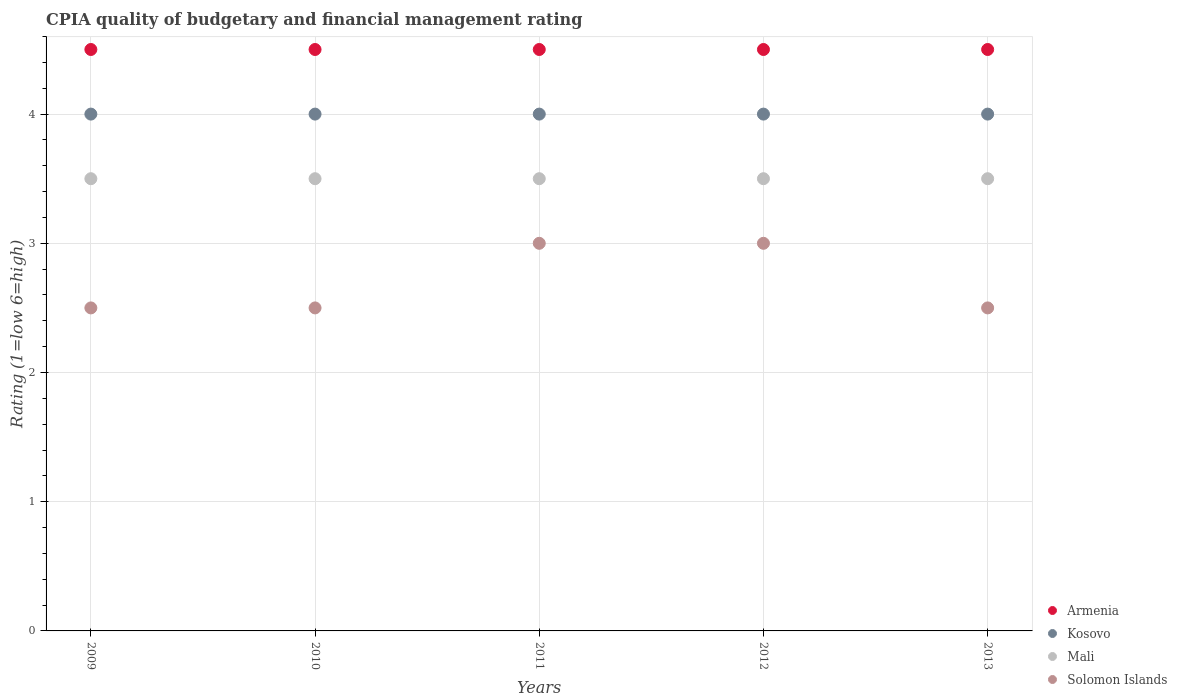How many different coloured dotlines are there?
Give a very brief answer. 4. Across all years, what is the maximum CPIA rating in Solomon Islands?
Offer a terse response. 3. In which year was the CPIA rating in Kosovo minimum?
Your response must be concise. 2009. What is the difference between the CPIA rating in Mali in 2009 and that in 2012?
Keep it short and to the point. 0. What is the average CPIA rating in Armenia per year?
Provide a short and direct response. 4.5. In the year 2013, what is the difference between the CPIA rating in Armenia and CPIA rating in Mali?
Your answer should be compact. 1. What is the ratio of the CPIA rating in Kosovo in 2009 to that in 2013?
Ensure brevity in your answer.  1. What is the difference between the highest and the second highest CPIA rating in Kosovo?
Make the answer very short. 0. What is the difference between the highest and the lowest CPIA rating in Solomon Islands?
Offer a very short reply. 0.5. In how many years, is the CPIA rating in Mali greater than the average CPIA rating in Mali taken over all years?
Your answer should be very brief. 0. Is the CPIA rating in Solomon Islands strictly greater than the CPIA rating in Kosovo over the years?
Keep it short and to the point. No. How many years are there in the graph?
Your answer should be very brief. 5. Does the graph contain any zero values?
Offer a terse response. No. Does the graph contain grids?
Give a very brief answer. Yes. Where does the legend appear in the graph?
Offer a terse response. Bottom right. How many legend labels are there?
Your response must be concise. 4. How are the legend labels stacked?
Offer a very short reply. Vertical. What is the title of the graph?
Make the answer very short. CPIA quality of budgetary and financial management rating. What is the Rating (1=low 6=high) in Armenia in 2009?
Keep it short and to the point. 4.5. What is the Rating (1=low 6=high) of Solomon Islands in 2009?
Provide a succinct answer. 2.5. What is the Rating (1=low 6=high) of Mali in 2010?
Ensure brevity in your answer.  3.5. What is the Rating (1=low 6=high) in Solomon Islands in 2010?
Offer a terse response. 2.5. What is the Rating (1=low 6=high) in Armenia in 2011?
Ensure brevity in your answer.  4.5. What is the Rating (1=low 6=high) in Kosovo in 2011?
Make the answer very short. 4. What is the Rating (1=low 6=high) in Solomon Islands in 2011?
Ensure brevity in your answer.  3. What is the Rating (1=low 6=high) of Armenia in 2012?
Make the answer very short. 4.5. What is the Rating (1=low 6=high) of Mali in 2012?
Provide a short and direct response. 3.5. What is the Rating (1=low 6=high) in Armenia in 2013?
Ensure brevity in your answer.  4.5. What is the Rating (1=low 6=high) in Mali in 2013?
Offer a very short reply. 3.5. What is the Rating (1=low 6=high) in Solomon Islands in 2013?
Make the answer very short. 2.5. Across all years, what is the maximum Rating (1=low 6=high) in Armenia?
Offer a very short reply. 4.5. Across all years, what is the maximum Rating (1=low 6=high) of Kosovo?
Offer a terse response. 4. Across all years, what is the maximum Rating (1=low 6=high) of Mali?
Offer a terse response. 3.5. Across all years, what is the minimum Rating (1=low 6=high) of Kosovo?
Ensure brevity in your answer.  4. Across all years, what is the minimum Rating (1=low 6=high) in Mali?
Make the answer very short. 3.5. What is the total Rating (1=low 6=high) in Armenia in the graph?
Give a very brief answer. 22.5. What is the total Rating (1=low 6=high) of Kosovo in the graph?
Ensure brevity in your answer.  20. What is the total Rating (1=low 6=high) in Mali in the graph?
Give a very brief answer. 17.5. What is the total Rating (1=low 6=high) of Solomon Islands in the graph?
Your answer should be compact. 13.5. What is the difference between the Rating (1=low 6=high) in Solomon Islands in 2009 and that in 2010?
Offer a terse response. 0. What is the difference between the Rating (1=low 6=high) in Mali in 2009 and that in 2011?
Ensure brevity in your answer.  0. What is the difference between the Rating (1=low 6=high) of Solomon Islands in 2009 and that in 2012?
Offer a very short reply. -0.5. What is the difference between the Rating (1=low 6=high) of Armenia in 2009 and that in 2013?
Keep it short and to the point. 0. What is the difference between the Rating (1=low 6=high) in Armenia in 2010 and that in 2011?
Ensure brevity in your answer.  0. What is the difference between the Rating (1=low 6=high) of Mali in 2010 and that in 2011?
Provide a short and direct response. 0. What is the difference between the Rating (1=low 6=high) of Kosovo in 2010 and that in 2012?
Keep it short and to the point. 0. What is the difference between the Rating (1=low 6=high) in Mali in 2010 and that in 2012?
Give a very brief answer. 0. What is the difference between the Rating (1=low 6=high) of Solomon Islands in 2010 and that in 2012?
Your response must be concise. -0.5. What is the difference between the Rating (1=low 6=high) of Armenia in 2010 and that in 2013?
Make the answer very short. 0. What is the difference between the Rating (1=low 6=high) in Mali in 2010 and that in 2013?
Your response must be concise. 0. What is the difference between the Rating (1=low 6=high) in Armenia in 2011 and that in 2012?
Provide a short and direct response. 0. What is the difference between the Rating (1=low 6=high) in Solomon Islands in 2011 and that in 2012?
Your answer should be compact. 0. What is the difference between the Rating (1=low 6=high) in Armenia in 2011 and that in 2013?
Ensure brevity in your answer.  0. What is the difference between the Rating (1=low 6=high) of Solomon Islands in 2011 and that in 2013?
Make the answer very short. 0.5. What is the difference between the Rating (1=low 6=high) of Kosovo in 2012 and that in 2013?
Offer a terse response. 0. What is the difference between the Rating (1=low 6=high) of Kosovo in 2009 and the Rating (1=low 6=high) of Mali in 2010?
Your answer should be compact. 0.5. What is the difference between the Rating (1=low 6=high) of Armenia in 2009 and the Rating (1=low 6=high) of Kosovo in 2012?
Make the answer very short. 0.5. What is the difference between the Rating (1=low 6=high) of Armenia in 2009 and the Rating (1=low 6=high) of Mali in 2012?
Offer a very short reply. 1. What is the difference between the Rating (1=low 6=high) of Armenia in 2009 and the Rating (1=low 6=high) of Solomon Islands in 2012?
Your answer should be very brief. 1.5. What is the difference between the Rating (1=low 6=high) in Kosovo in 2009 and the Rating (1=low 6=high) in Solomon Islands in 2012?
Your answer should be compact. 1. What is the difference between the Rating (1=low 6=high) of Armenia in 2009 and the Rating (1=low 6=high) of Kosovo in 2013?
Your answer should be compact. 0.5. What is the difference between the Rating (1=low 6=high) in Armenia in 2009 and the Rating (1=low 6=high) in Solomon Islands in 2013?
Make the answer very short. 2. What is the difference between the Rating (1=low 6=high) of Mali in 2009 and the Rating (1=low 6=high) of Solomon Islands in 2013?
Make the answer very short. 1. What is the difference between the Rating (1=low 6=high) in Armenia in 2010 and the Rating (1=low 6=high) in Kosovo in 2011?
Your answer should be compact. 0.5. What is the difference between the Rating (1=low 6=high) in Armenia in 2010 and the Rating (1=low 6=high) in Mali in 2011?
Offer a terse response. 1. What is the difference between the Rating (1=low 6=high) of Armenia in 2010 and the Rating (1=low 6=high) of Solomon Islands in 2011?
Your response must be concise. 1.5. What is the difference between the Rating (1=low 6=high) in Kosovo in 2010 and the Rating (1=low 6=high) in Solomon Islands in 2011?
Offer a very short reply. 1. What is the difference between the Rating (1=low 6=high) in Armenia in 2010 and the Rating (1=low 6=high) in Mali in 2012?
Keep it short and to the point. 1. What is the difference between the Rating (1=low 6=high) of Kosovo in 2010 and the Rating (1=low 6=high) of Mali in 2012?
Make the answer very short. 0.5. What is the difference between the Rating (1=low 6=high) in Mali in 2010 and the Rating (1=low 6=high) in Solomon Islands in 2012?
Provide a succinct answer. 0.5. What is the difference between the Rating (1=low 6=high) of Armenia in 2010 and the Rating (1=low 6=high) of Solomon Islands in 2013?
Your answer should be very brief. 2. What is the difference between the Rating (1=low 6=high) in Kosovo in 2010 and the Rating (1=low 6=high) in Mali in 2013?
Provide a succinct answer. 0.5. What is the difference between the Rating (1=low 6=high) in Armenia in 2011 and the Rating (1=low 6=high) in Mali in 2012?
Offer a terse response. 1. What is the difference between the Rating (1=low 6=high) in Kosovo in 2011 and the Rating (1=low 6=high) in Solomon Islands in 2012?
Offer a very short reply. 1. What is the difference between the Rating (1=low 6=high) of Mali in 2011 and the Rating (1=low 6=high) of Solomon Islands in 2012?
Give a very brief answer. 0.5. What is the difference between the Rating (1=low 6=high) of Armenia in 2011 and the Rating (1=low 6=high) of Kosovo in 2013?
Ensure brevity in your answer.  0.5. What is the difference between the Rating (1=low 6=high) of Kosovo in 2011 and the Rating (1=low 6=high) of Solomon Islands in 2013?
Your answer should be compact. 1.5. What is the difference between the Rating (1=low 6=high) in Mali in 2011 and the Rating (1=low 6=high) in Solomon Islands in 2013?
Make the answer very short. 1. What is the difference between the Rating (1=low 6=high) of Armenia in 2012 and the Rating (1=low 6=high) of Kosovo in 2013?
Your response must be concise. 0.5. What is the difference between the Rating (1=low 6=high) of Armenia in 2012 and the Rating (1=low 6=high) of Mali in 2013?
Offer a terse response. 1. What is the difference between the Rating (1=low 6=high) in Armenia in 2012 and the Rating (1=low 6=high) in Solomon Islands in 2013?
Provide a succinct answer. 2. What is the average Rating (1=low 6=high) in Armenia per year?
Make the answer very short. 4.5. In the year 2009, what is the difference between the Rating (1=low 6=high) in Armenia and Rating (1=low 6=high) in Kosovo?
Provide a short and direct response. 0.5. In the year 2009, what is the difference between the Rating (1=low 6=high) of Armenia and Rating (1=low 6=high) of Mali?
Your response must be concise. 1. In the year 2009, what is the difference between the Rating (1=low 6=high) of Kosovo and Rating (1=low 6=high) of Mali?
Keep it short and to the point. 0.5. In the year 2009, what is the difference between the Rating (1=low 6=high) in Kosovo and Rating (1=low 6=high) in Solomon Islands?
Your answer should be compact. 1.5. In the year 2009, what is the difference between the Rating (1=low 6=high) in Mali and Rating (1=low 6=high) in Solomon Islands?
Ensure brevity in your answer.  1. In the year 2010, what is the difference between the Rating (1=low 6=high) of Armenia and Rating (1=low 6=high) of Kosovo?
Offer a terse response. 0.5. In the year 2010, what is the difference between the Rating (1=low 6=high) in Kosovo and Rating (1=low 6=high) in Mali?
Ensure brevity in your answer.  0.5. In the year 2011, what is the difference between the Rating (1=low 6=high) of Armenia and Rating (1=low 6=high) of Kosovo?
Give a very brief answer. 0.5. In the year 2012, what is the difference between the Rating (1=low 6=high) of Kosovo and Rating (1=low 6=high) of Solomon Islands?
Your answer should be very brief. 1. In the year 2012, what is the difference between the Rating (1=low 6=high) in Mali and Rating (1=low 6=high) in Solomon Islands?
Offer a terse response. 0.5. In the year 2013, what is the difference between the Rating (1=low 6=high) of Armenia and Rating (1=low 6=high) of Kosovo?
Provide a short and direct response. 0.5. In the year 2013, what is the difference between the Rating (1=low 6=high) of Armenia and Rating (1=low 6=high) of Mali?
Ensure brevity in your answer.  1. In the year 2013, what is the difference between the Rating (1=low 6=high) in Kosovo and Rating (1=low 6=high) in Mali?
Provide a short and direct response. 0.5. In the year 2013, what is the difference between the Rating (1=low 6=high) of Kosovo and Rating (1=low 6=high) of Solomon Islands?
Ensure brevity in your answer.  1.5. What is the ratio of the Rating (1=low 6=high) in Armenia in 2009 to that in 2010?
Offer a terse response. 1. What is the ratio of the Rating (1=low 6=high) of Kosovo in 2009 to that in 2010?
Your answer should be very brief. 1. What is the ratio of the Rating (1=low 6=high) of Mali in 2009 to that in 2010?
Offer a terse response. 1. What is the ratio of the Rating (1=low 6=high) of Armenia in 2009 to that in 2011?
Keep it short and to the point. 1. What is the ratio of the Rating (1=low 6=high) in Mali in 2009 to that in 2011?
Your answer should be compact. 1. What is the ratio of the Rating (1=low 6=high) in Solomon Islands in 2009 to that in 2012?
Provide a succinct answer. 0.83. What is the ratio of the Rating (1=low 6=high) in Mali in 2009 to that in 2013?
Your response must be concise. 1. What is the ratio of the Rating (1=low 6=high) of Solomon Islands in 2009 to that in 2013?
Offer a terse response. 1. What is the ratio of the Rating (1=low 6=high) of Armenia in 2010 to that in 2011?
Your answer should be very brief. 1. What is the ratio of the Rating (1=low 6=high) of Mali in 2010 to that in 2011?
Give a very brief answer. 1. What is the ratio of the Rating (1=low 6=high) of Armenia in 2010 to that in 2012?
Offer a terse response. 1. What is the ratio of the Rating (1=low 6=high) in Kosovo in 2010 to that in 2013?
Give a very brief answer. 1. What is the ratio of the Rating (1=low 6=high) of Solomon Islands in 2010 to that in 2013?
Make the answer very short. 1. What is the ratio of the Rating (1=low 6=high) of Kosovo in 2011 to that in 2012?
Provide a short and direct response. 1. What is the ratio of the Rating (1=low 6=high) of Solomon Islands in 2011 to that in 2012?
Make the answer very short. 1. What is the ratio of the Rating (1=low 6=high) of Armenia in 2011 to that in 2013?
Your answer should be compact. 1. What is the ratio of the Rating (1=low 6=high) in Kosovo in 2011 to that in 2013?
Keep it short and to the point. 1. What is the ratio of the Rating (1=low 6=high) of Mali in 2011 to that in 2013?
Keep it short and to the point. 1. What is the ratio of the Rating (1=low 6=high) of Solomon Islands in 2011 to that in 2013?
Your response must be concise. 1.2. What is the ratio of the Rating (1=low 6=high) in Armenia in 2012 to that in 2013?
Offer a very short reply. 1. What is the ratio of the Rating (1=low 6=high) in Mali in 2012 to that in 2013?
Offer a terse response. 1. What is the difference between the highest and the second highest Rating (1=low 6=high) in Armenia?
Offer a very short reply. 0. What is the difference between the highest and the second highest Rating (1=low 6=high) in Kosovo?
Give a very brief answer. 0. What is the difference between the highest and the second highest Rating (1=low 6=high) of Mali?
Make the answer very short. 0. What is the difference between the highest and the second highest Rating (1=low 6=high) in Solomon Islands?
Provide a succinct answer. 0. What is the difference between the highest and the lowest Rating (1=low 6=high) of Mali?
Make the answer very short. 0. 